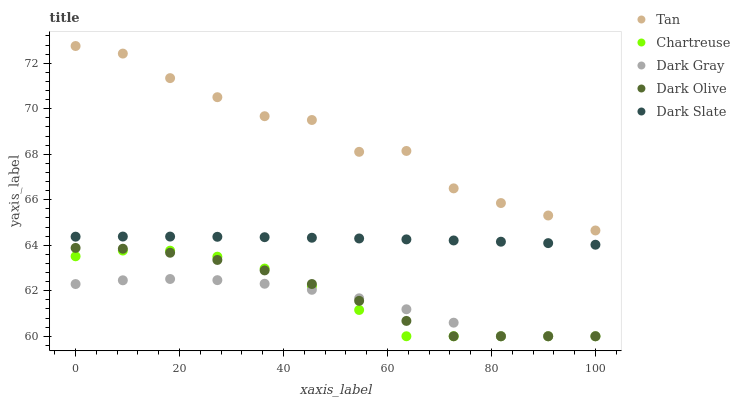Does Dark Gray have the minimum area under the curve?
Answer yes or no. Yes. Does Tan have the maximum area under the curve?
Answer yes or no. Yes. Does Dark Slate have the minimum area under the curve?
Answer yes or no. No. Does Dark Slate have the maximum area under the curve?
Answer yes or no. No. Is Dark Slate the smoothest?
Answer yes or no. Yes. Is Tan the roughest?
Answer yes or no. Yes. Is Tan the smoothest?
Answer yes or no. No. Is Dark Slate the roughest?
Answer yes or no. No. Does Dark Gray have the lowest value?
Answer yes or no. Yes. Does Dark Slate have the lowest value?
Answer yes or no. No. Does Tan have the highest value?
Answer yes or no. Yes. Does Dark Slate have the highest value?
Answer yes or no. No. Is Dark Olive less than Dark Slate?
Answer yes or no. Yes. Is Dark Slate greater than Dark Gray?
Answer yes or no. Yes. Does Chartreuse intersect Dark Olive?
Answer yes or no. Yes. Is Chartreuse less than Dark Olive?
Answer yes or no. No. Is Chartreuse greater than Dark Olive?
Answer yes or no. No. Does Dark Olive intersect Dark Slate?
Answer yes or no. No. 